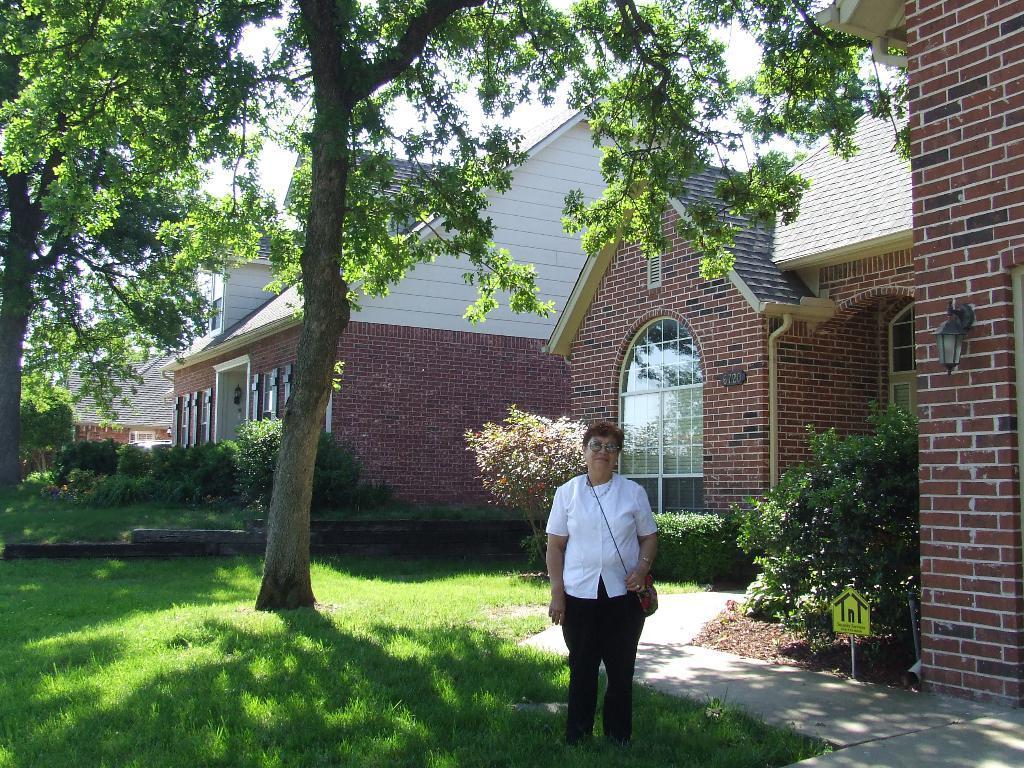Please provide a concise description of this image. In this picture I can observe a woman standing on the ground. There is some grass on the ground. I can observe some plants and trees. In the background there are houses and I can observe sky. 